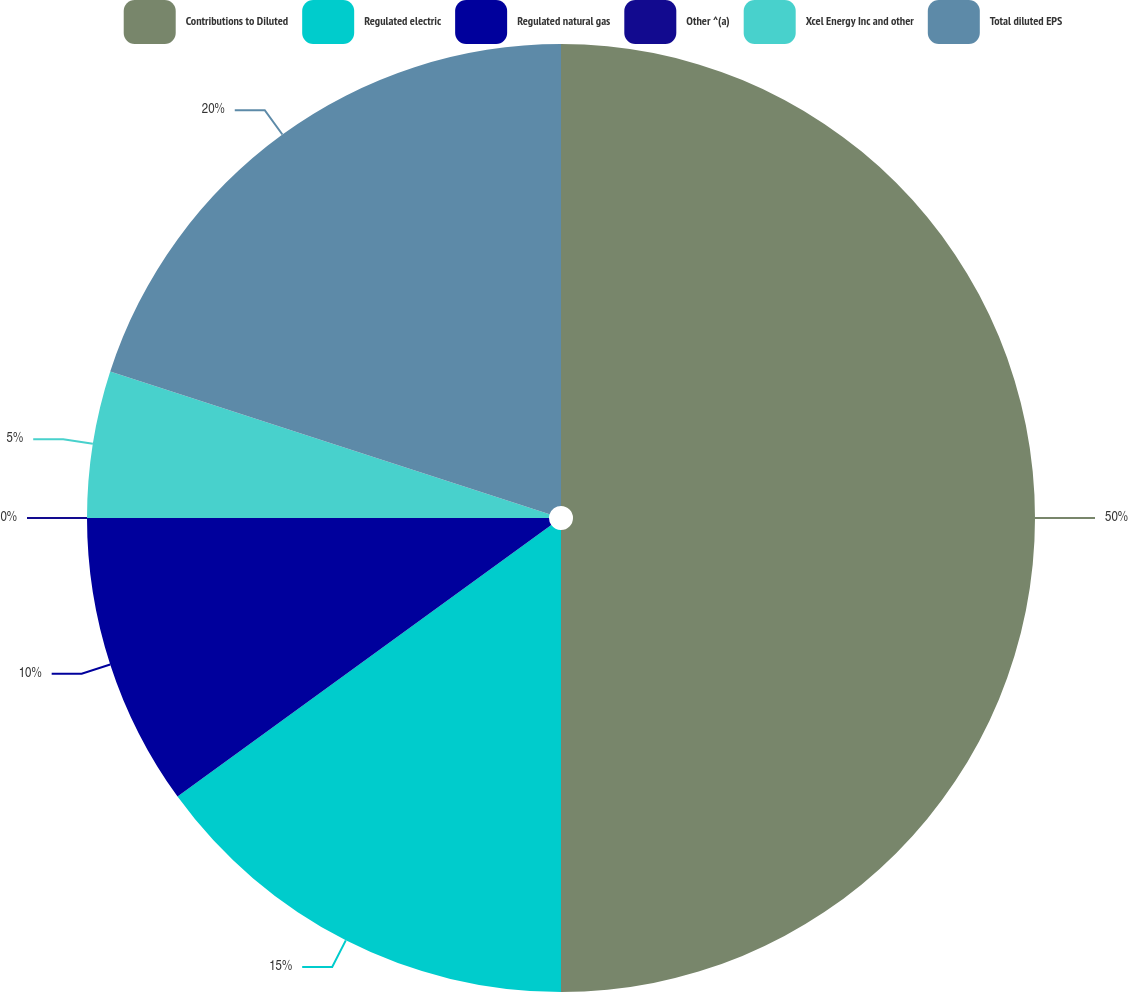<chart> <loc_0><loc_0><loc_500><loc_500><pie_chart><fcel>Contributions to Diluted<fcel>Regulated electric<fcel>Regulated natural gas<fcel>Other ^(a)<fcel>Xcel Energy Inc and other<fcel>Total diluted EPS<nl><fcel>50.0%<fcel>15.0%<fcel>10.0%<fcel>0.0%<fcel>5.0%<fcel>20.0%<nl></chart> 